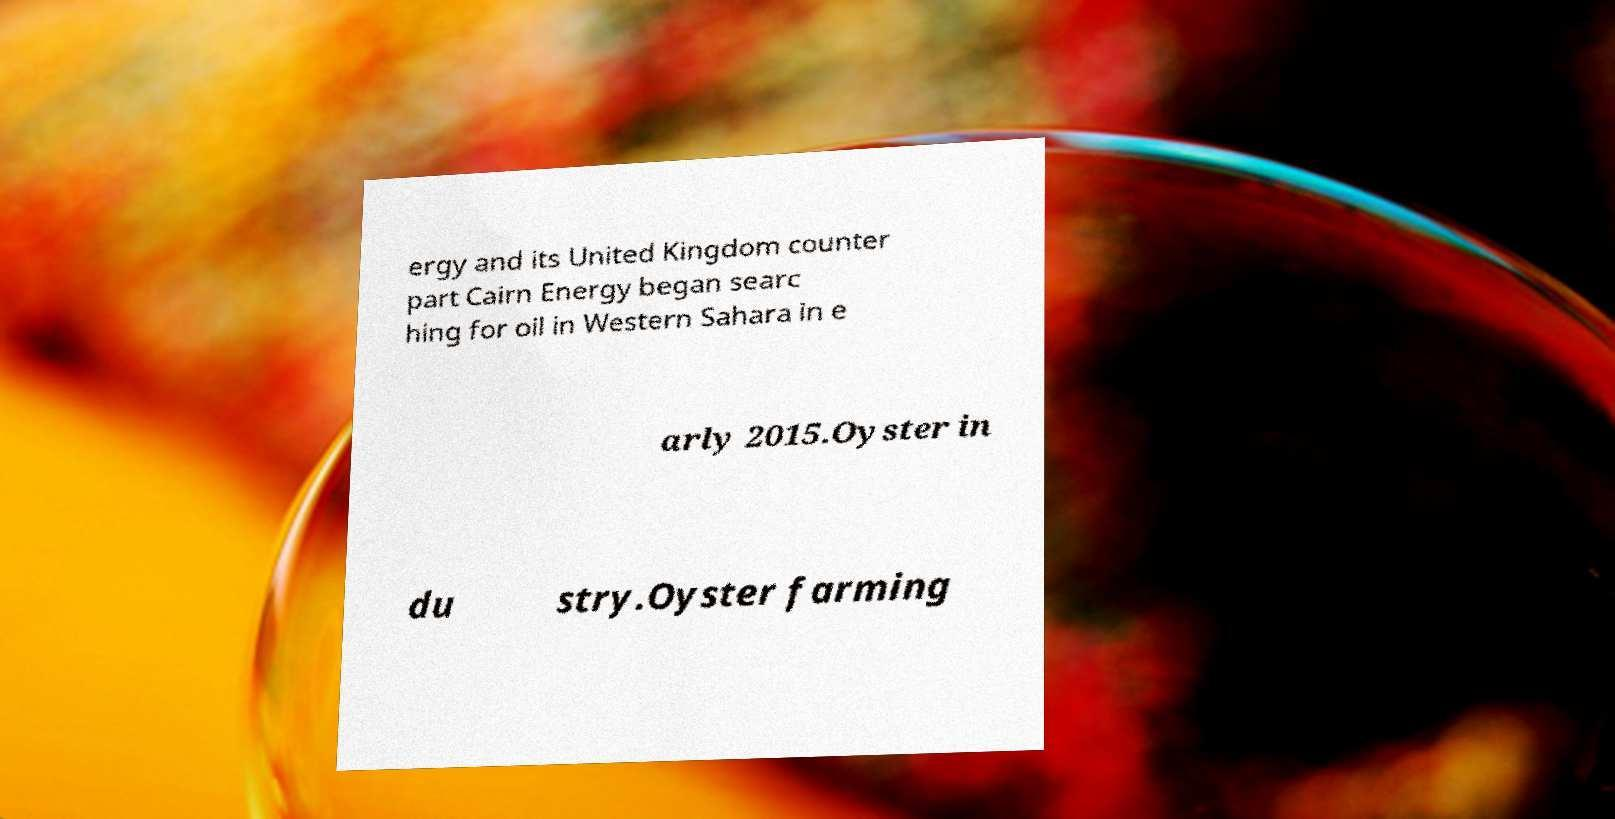There's text embedded in this image that I need extracted. Can you transcribe it verbatim? ergy and its United Kingdom counter part Cairn Energy began searc hing for oil in Western Sahara in e arly 2015.Oyster in du stry.Oyster farming 